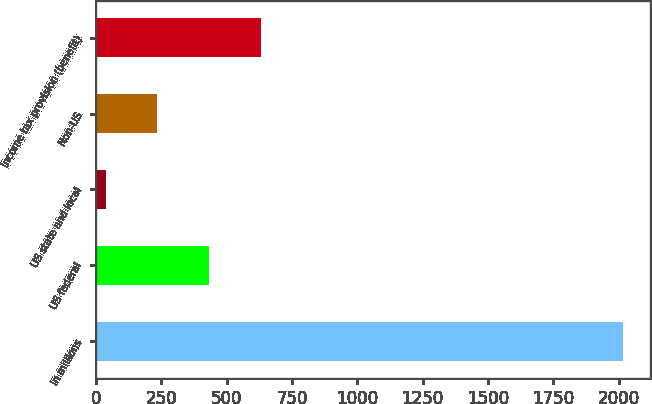Convert chart. <chart><loc_0><loc_0><loc_500><loc_500><bar_chart><fcel>In millions<fcel>US federal<fcel>US state and local<fcel>Non-US<fcel>Income tax provision (benefit)<nl><fcel>2018<fcel>433.2<fcel>37<fcel>235.1<fcel>631.3<nl></chart> 